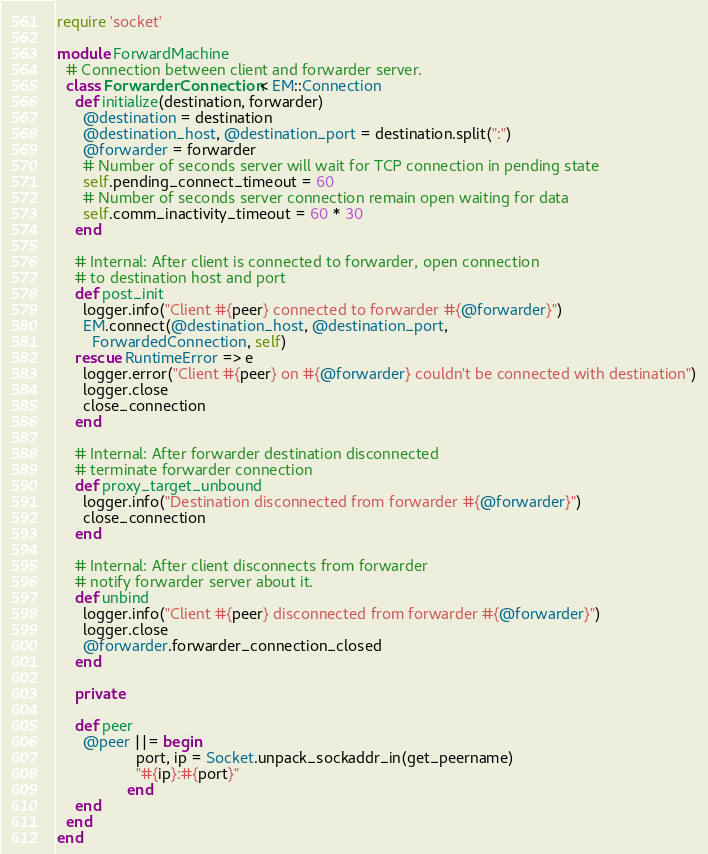<code> <loc_0><loc_0><loc_500><loc_500><_Ruby_>require 'socket'

module ForwardMachine
  # Connection between client and forwarder server.
  class ForwarderConnection < EM::Connection
    def initialize(destination, forwarder)
      @destination = destination
      @destination_host, @destination_port = destination.split(":")
      @forwarder = forwarder
      # Number of seconds server will wait for TCP connection in pending state
      self.pending_connect_timeout = 60
      # Number of seconds server connection remain open waiting for data
      self.comm_inactivity_timeout = 60 * 30
    end

    # Internal: After client is connected to forwarder, open connection
    # to destination host and port
    def post_init
      logger.info("Client #{peer} connected to forwarder #{@forwarder}")
      EM.connect(@destination_host, @destination_port,
        ForwardedConnection, self)
    rescue RuntimeError => e
      logger.error("Client #{peer} on #{@forwarder} couldn't be connected with destination")
      logger.close
      close_connection
    end

    # Internal: After forwarder destination disconnected
    # terminate forwarder connection
    def proxy_target_unbound
      logger.info("Destination disconnected from forwarder #{@forwarder}")
      close_connection
    end

    # Internal: After client disconnects from forwarder
    # notify forwarder server about it.
    def unbind
      logger.info("Client #{peer} disconnected from forwarder #{@forwarder}")
      logger.close
      @forwarder.forwarder_connection_closed
    end

    private

    def peer
      @peer ||= begin
                  port, ip = Socket.unpack_sockaddr_in(get_peername)
                  "#{ip}:#{port}"
                end
    end
  end
end
</code> 